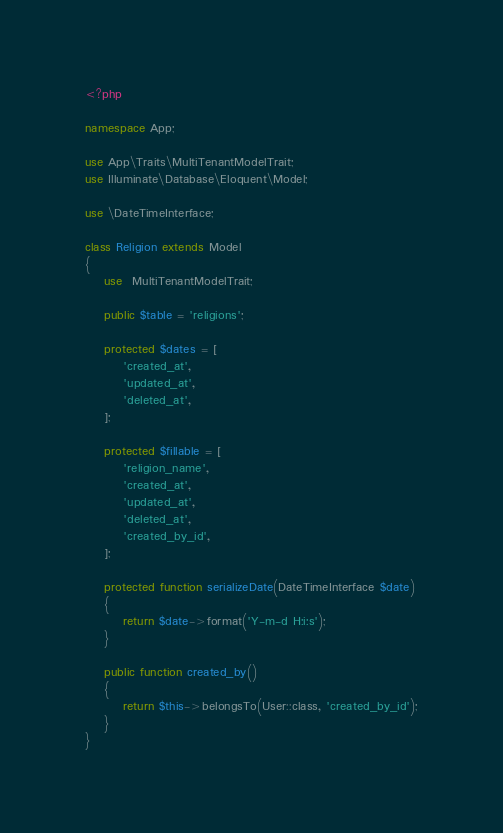<code> <loc_0><loc_0><loc_500><loc_500><_PHP_><?php

namespace App;

use App\Traits\MultiTenantModelTrait;
use Illuminate\Database\Eloquent\Model;

use \DateTimeInterface;

class Religion extends Model
{
    use  MultiTenantModelTrait;

    public $table = 'religions';

    protected $dates = [
        'created_at',
        'updated_at',
        'deleted_at',
    ];

    protected $fillable = [
        'religion_name',
        'created_at',
        'updated_at',
        'deleted_at',
        'created_by_id',
    ];

    protected function serializeDate(DateTimeInterface $date)
    {
        return $date->format('Y-m-d H:i:s');
    }

    public function created_by()
    {
        return $this->belongsTo(User::class, 'created_by_id');
    }
}
</code> 